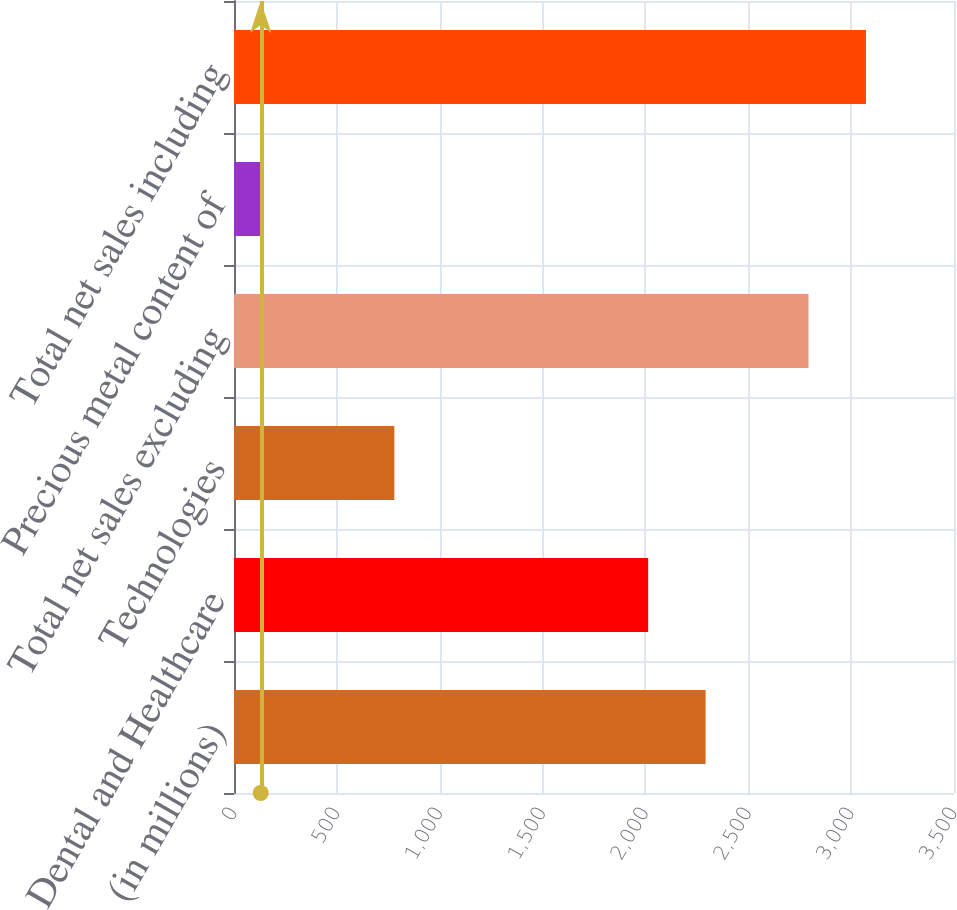Convert chart to OTSL. <chart><loc_0><loc_0><loc_500><loc_500><bar_chart><fcel>(in millions)<fcel>Dental and Healthcare<fcel>Technologies<fcel>Total net sales excluding<fcel>Precious metal content of<fcel>Total net sales including<nl><fcel>2292.47<fcel>2013.2<fcel>779.5<fcel>2792.7<fcel>129.9<fcel>3071.97<nl></chart> 